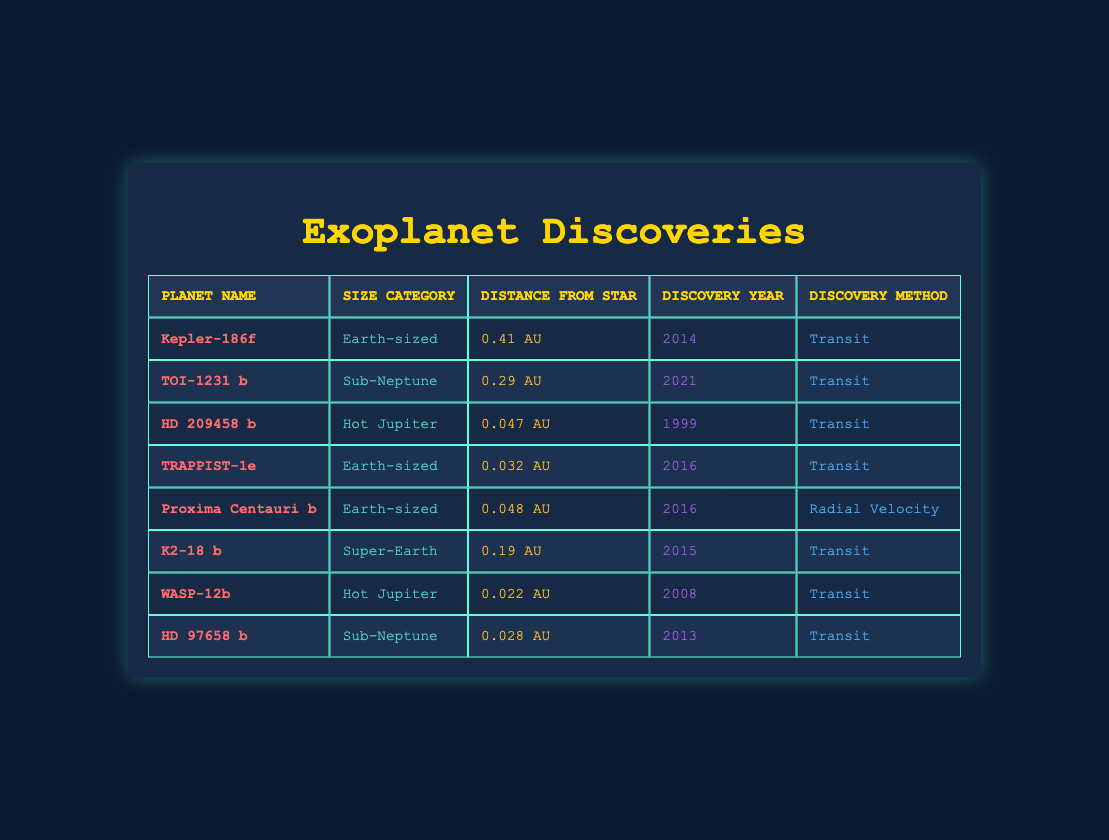What is the size category of Proxima Centauri b? The table lists each planet's size category in the second column. Proxima Centauri b is listed with the size category "Earth-sized."
Answer: Earth-sized How many exoplanets were discovered in the year 2016? By inspecting the discovery year column, we can count the entries for 2016. There are two exoplanets listed for that year: TRAPPIST-1e and Proxima Centauri b.
Answer: 2 What discovery method was used for WASP-12b? The method of discovery for each exoplanet is listed in the last column. For WASP-12b, the discovery method is stated as "Transit."
Answer: Transit Is there an exoplanet categorized as a Super-Earth? Looking through the size category column, we find that K2-18 b is listed as a "Super-Earth." Therefore, the statement is true.
Answer: Yes What is the average distance from the star for Earth-sized exoplanets? We find three Earth-sized exoplanets: Kepler-186f (0.41 AU), TRAPPIST-1e (0.032 AU), and Proxima Centauri b (0.048 AU). We calculate the average by summing their distances (0.41 + 0.032 + 0.048 = 0.49 AU) and dividing by three (0.49 / 3 ≈ 0.1633 AU). Thus, the average distance is approximately 0.1633 AU.
Answer: 0.1633 AU Which size category has the most exoplanets in the table? To determine which size category has the most exoplanets, we count the occurrences of each size category in the table. The counts are: Earth-sized (3), Sub-Neptune (2), Hot Jupiter (2), Super-Earth (1). Earth-sized has the highest count with 3 exoplanets.
Answer: Earth-sized What is the distance from star for HD 209458 b? The distance from the star for HD 209458 b can be found in the distance from star column, where it is listed as "0.047 AU."
Answer: 0.047 AU Are there any exoplanets discovered using the Radial Velocity method? By checking the discovery method column, we see that Proxima Centauri b is the only exoplanet listed under the Radial Velocity method. The statement is true.
Answer: Yes What is the difference in discovery years between the earliest and latest exoplanets? The earliest discovery year in the table is 1999 (HD 209458 b), and the latest is 2021 (TOI-1231 b). The difference is calculated as 2021 - 1999 = 22 years.
Answer: 22 years 